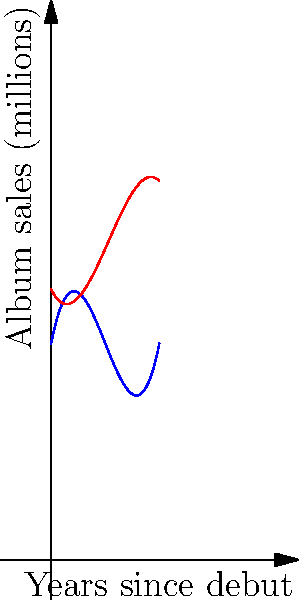The graph shows the album sales trends of two rival K-pop groups, A and B, over the first 10 years since their debut. Group A's sales are represented by the blue curve, while Group B's sales are represented by the red curve. Both trends can be modeled by cubic polynomials. Based on the graph, in which year after their debut did Group B overtake Group A in album sales? To find when Group B overtook Group A in album sales, we need to determine the point of intersection between the two curves. This is where the sales of both groups are equal.

Let's analyze the graph step-by-step:

1. At year 0 (debut), Group A starts with higher sales than Group B.

2. The blue curve (Group A) initially rises faster than the red curve (Group B).

3. As we move along the x-axis, we can see that the red curve intersects the blue curve at two points.

4. The first intersection occurs very early, likely before the first year. This doesn't represent Group B overtaking Group A, as Group A quickly regains the lead.

5. The second intersection is the point we're looking for. This occurs when the red curve crosses above the blue curve and stays above it.

6. By examining the graph closely, we can see that this second intersection occurs between year 6 and year 7 on the x-axis.

7. After this point, the red curve (Group B) remains above the blue curve (Group A), indicating that Group B has overtaken Group A in sales.

Therefore, Group B overtook Group A in album sales approximately 6-7 years after their debut.
Answer: Approximately 6-7 years after debut 